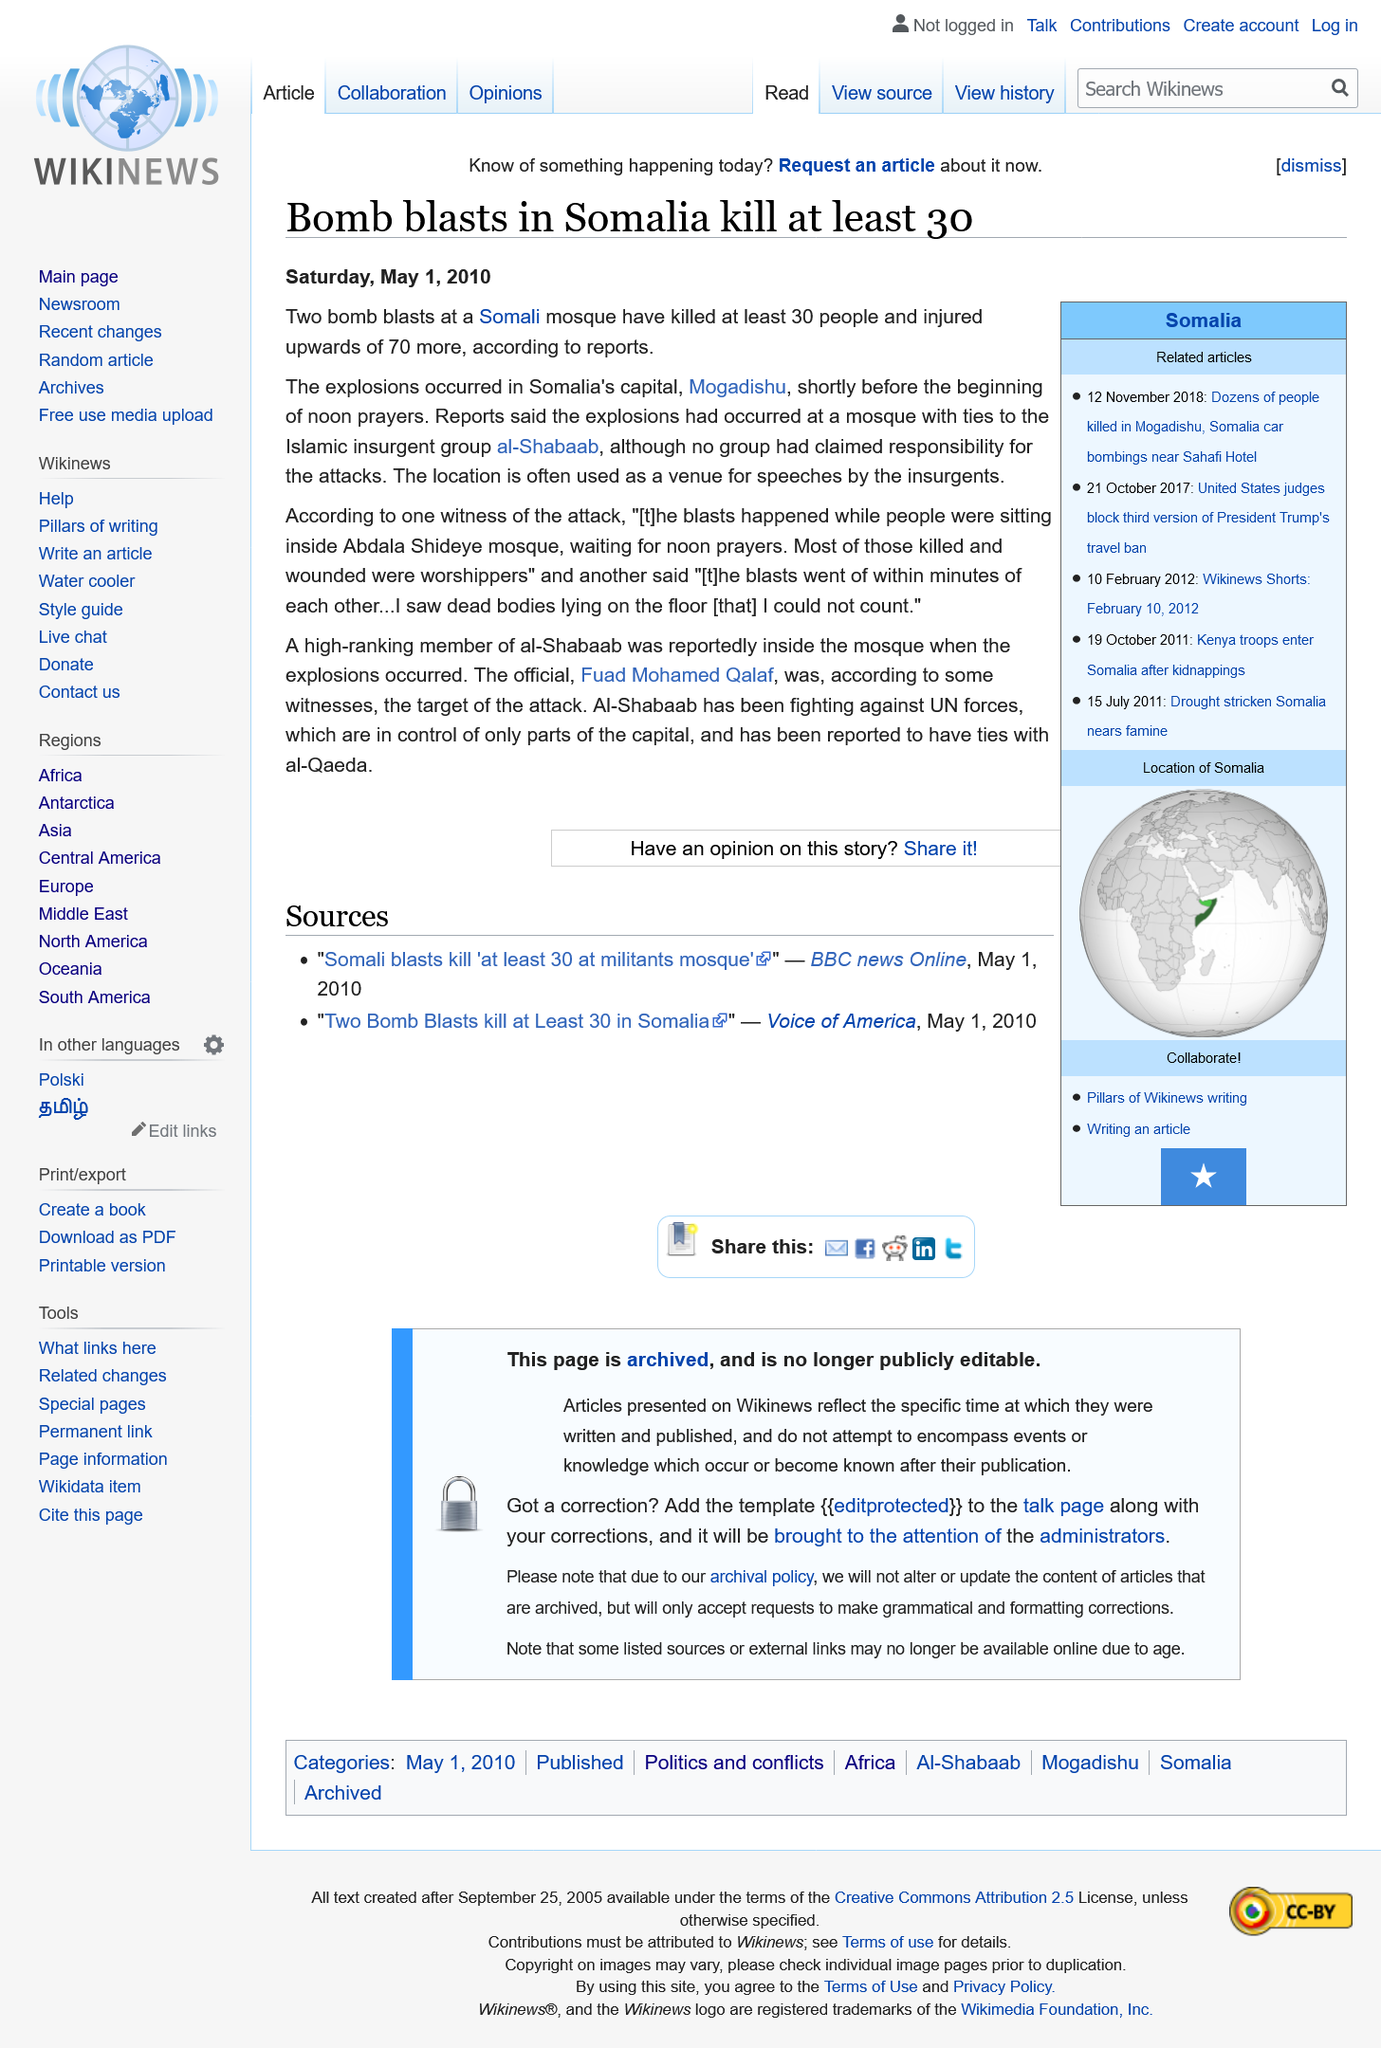Highlight a few significant elements in this photo. According to reports, at least 30 people were killed and upwards of 70 people were injured in the two bomb blasts that occurred in Mogadishu. In the capital city of Somalia, Mogadishu, two bomb blasts occurred, causing destruction and loss of life. Fuad Mohamed Qalaf, a high-ranking member of al-Shabaab, was reportedly inside the mosque when the explosions occurred, according to credible sources. 